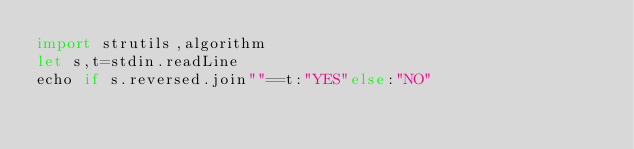Convert code to text. <code><loc_0><loc_0><loc_500><loc_500><_Nim_>import strutils,algorithm
let s,t=stdin.readLine
echo if s.reversed.join""==t:"YES"else:"NO"</code> 